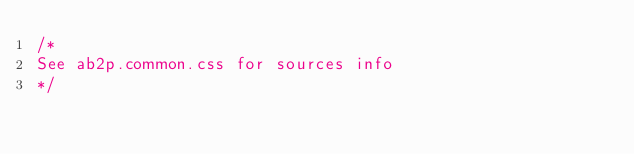Convert code to text. <code><loc_0><loc_0><loc_500><loc_500><_CSS_>/*
See ab2p.common.css for sources info
*/</code> 